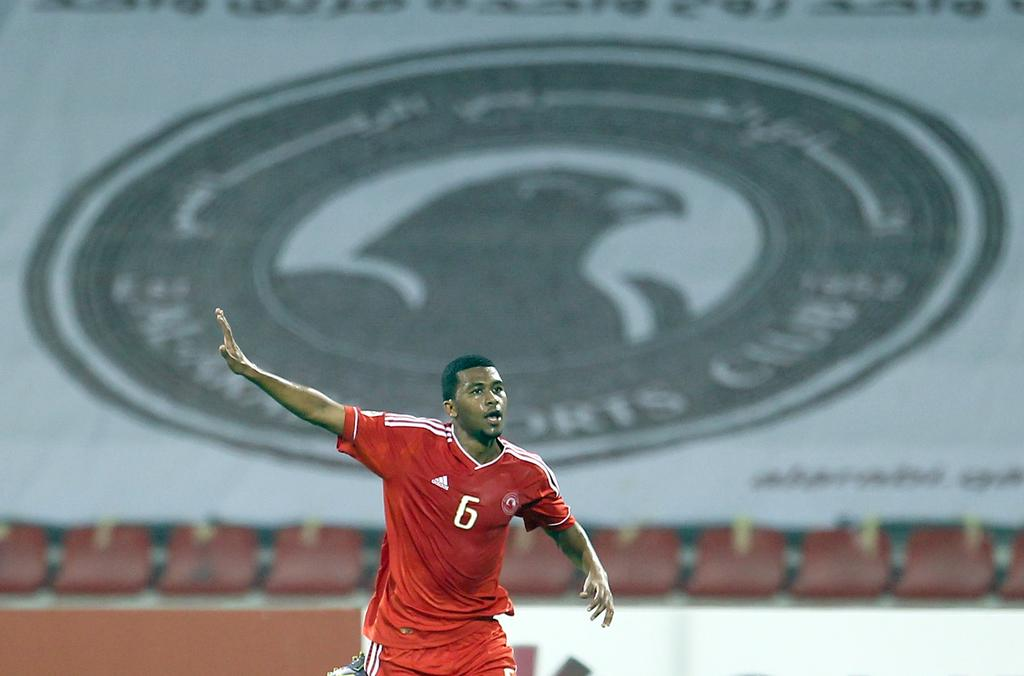<image>
Relay a brief, clear account of the picture shown. A large banner displaying a bird and the words SPORTS CLUB hangs in the background as a soccer player points. 